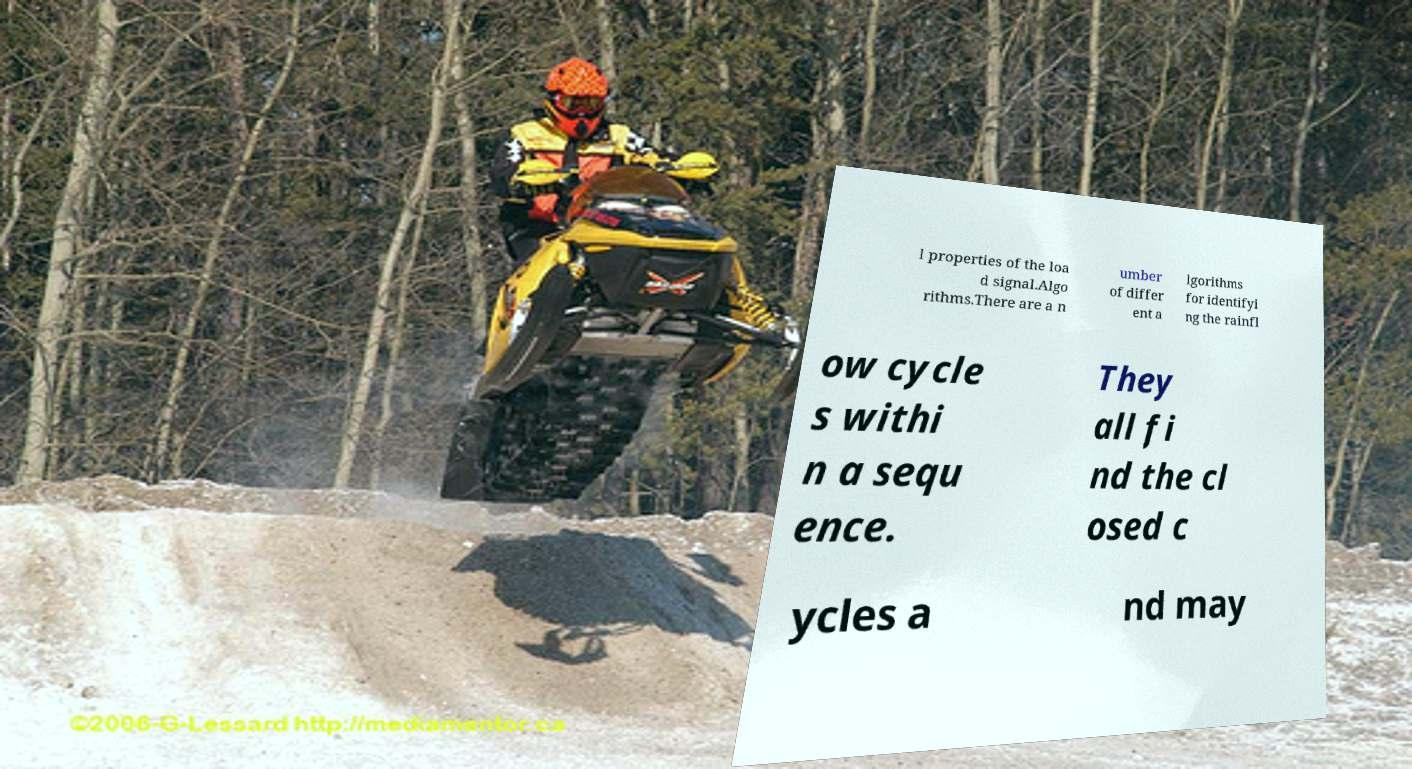Could you extract and type out the text from this image? l properties of the loa d signal.Algo rithms.There are a n umber of differ ent a lgorithms for identifyi ng the rainfl ow cycle s withi n a sequ ence. They all fi nd the cl osed c ycles a nd may 